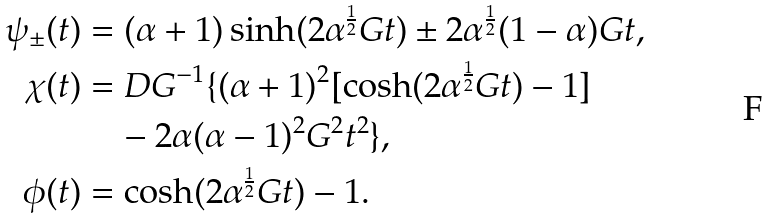Convert formula to latex. <formula><loc_0><loc_0><loc_500><loc_500>\psi _ { \pm } ( t ) & = ( \alpha + 1 ) \sinh ( 2 \alpha ^ { \frac { 1 } { 2 } } G t ) \pm 2 \alpha ^ { \frac { 1 } { 2 } } ( 1 - \alpha ) G t , \\ \chi ( t ) & = D G ^ { - 1 } \{ ( \alpha + 1 ) ^ { 2 } [ \cosh ( 2 \alpha ^ { \frac { 1 } { 2 } } G t ) - 1 ] \\ & \quad - 2 \alpha ( \alpha - 1 ) ^ { 2 } G ^ { 2 } t ^ { 2 } \} , \\ \phi ( t ) & = \cosh ( 2 \alpha ^ { \frac { 1 } { 2 } } G t ) - 1 .</formula> 